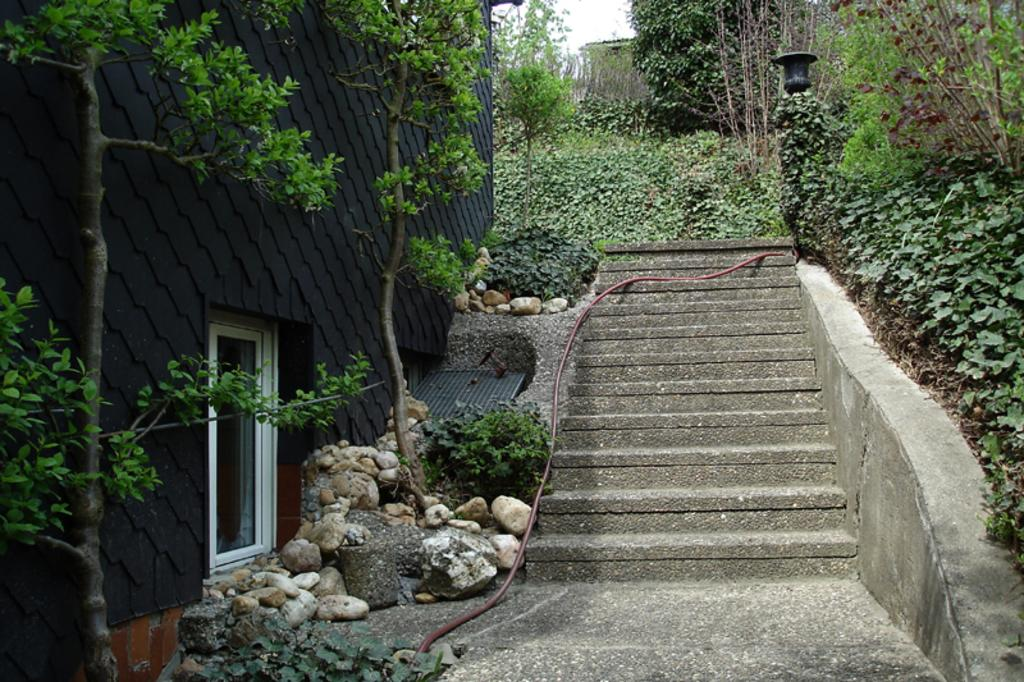What type of architectural feature can be seen in the image? There are steps in the image. What type of natural elements are present in the image? There are plants, trees, rocks, and stones in the image. Where are the rocks and stones located in the image? The rocks and stones are on the left side of the image. Is there any man-made structure near the rocks and stones? Yes, there is a window beside the rocks and stones. Can you see a rifle being used by someone in the image? No, there is no rifle present in the image. What type of muscle is being exercised by the plants in the image? Plants do not have muscles, so this question is not applicable to the image. 